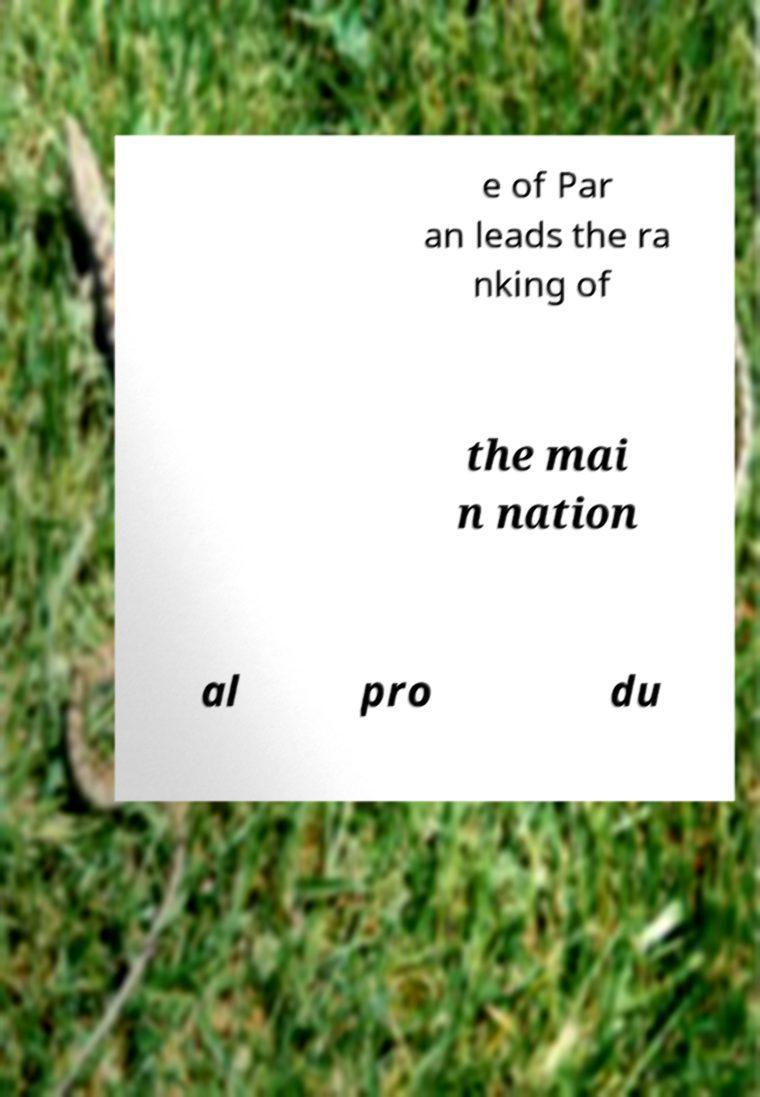Please identify and transcribe the text found in this image. e of Par an leads the ra nking of the mai n nation al pro du 